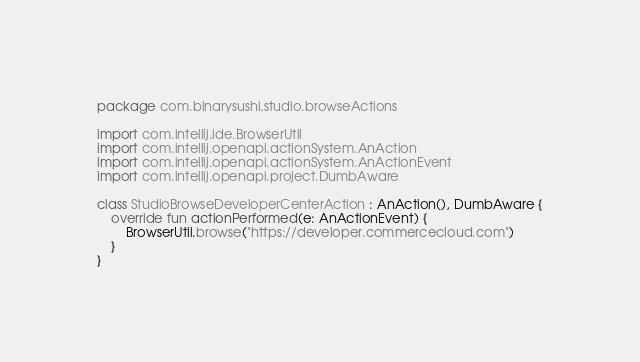<code> <loc_0><loc_0><loc_500><loc_500><_Kotlin_>package com.binarysushi.studio.browseActions

import com.intellij.ide.BrowserUtil
import com.intellij.openapi.actionSystem.AnAction
import com.intellij.openapi.actionSystem.AnActionEvent
import com.intellij.openapi.project.DumbAware

class StudioBrowseDeveloperCenterAction : AnAction(), DumbAware {
    override fun actionPerformed(e: AnActionEvent) {
        BrowserUtil.browse("https://developer.commercecloud.com")
    }
}
</code> 